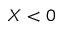<formula> <loc_0><loc_0><loc_500><loc_500>X < 0</formula> 